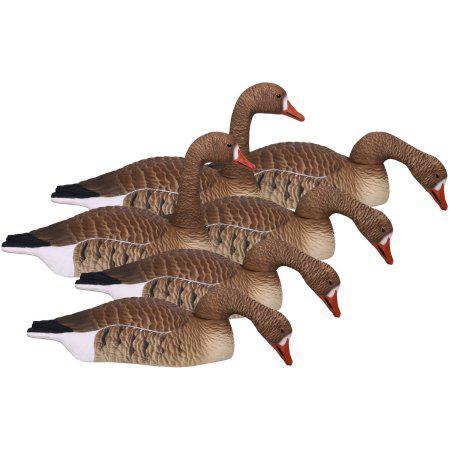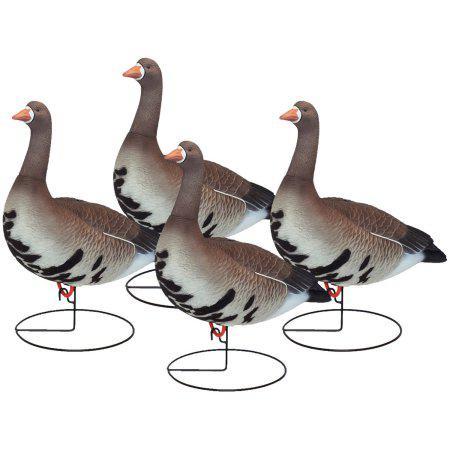The first image is the image on the left, the second image is the image on the right. Considering the images on both sides, is "All geese have flat bases without legs, black necks, and folded wings." valid? Answer yes or no. No. The first image is the image on the left, the second image is the image on the right. Assess this claim about the two images: "The geese in one image have dark orange beaks.". Correct or not? Answer yes or no. Yes. 